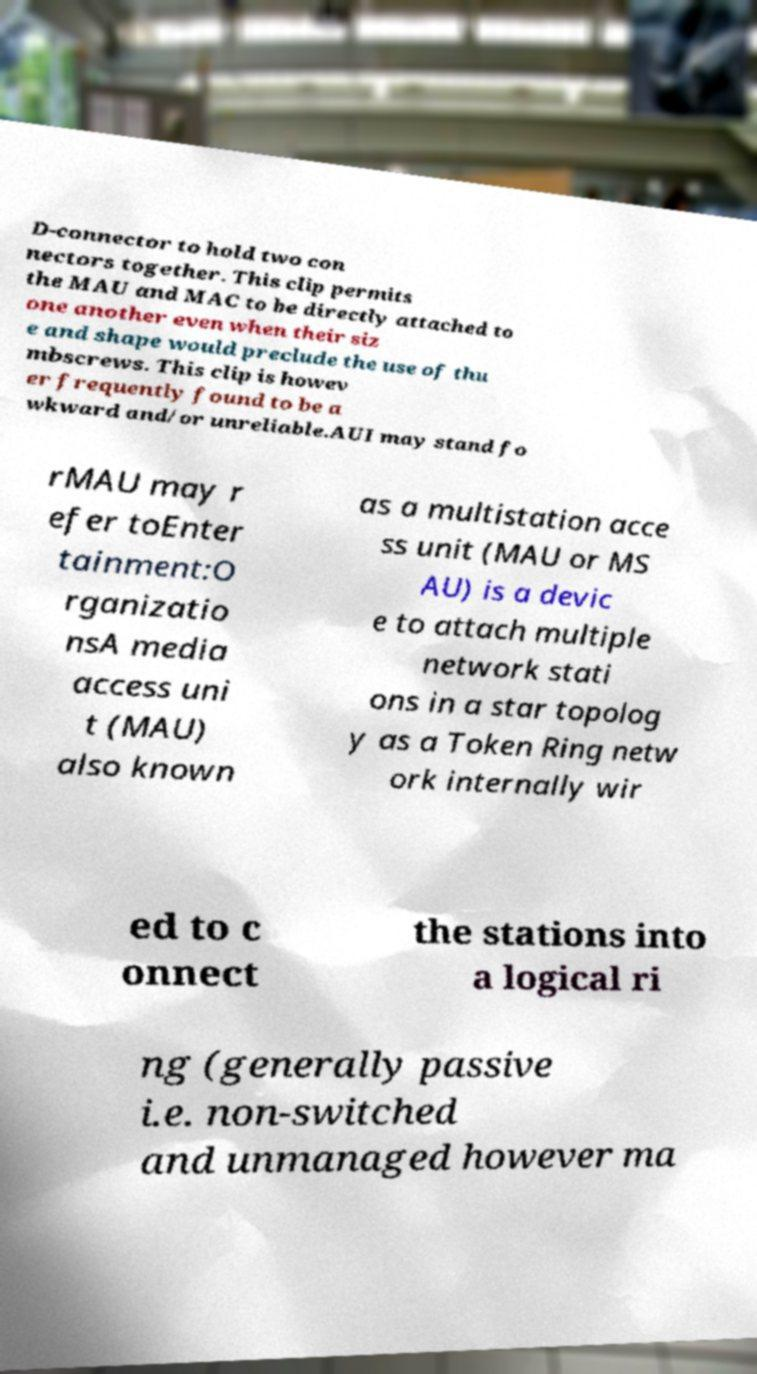Please identify and transcribe the text found in this image. D-connector to hold two con nectors together. This clip permits the MAU and MAC to be directly attached to one another even when their siz e and shape would preclude the use of thu mbscrews. This clip is howev er frequently found to be a wkward and/or unreliable.AUI may stand fo rMAU may r efer toEnter tainment:O rganizatio nsA media access uni t (MAU) also known as a multistation acce ss unit (MAU or MS AU) is a devic e to attach multiple network stati ons in a star topolog y as a Token Ring netw ork internally wir ed to c onnect the stations into a logical ri ng (generally passive i.e. non-switched and unmanaged however ma 